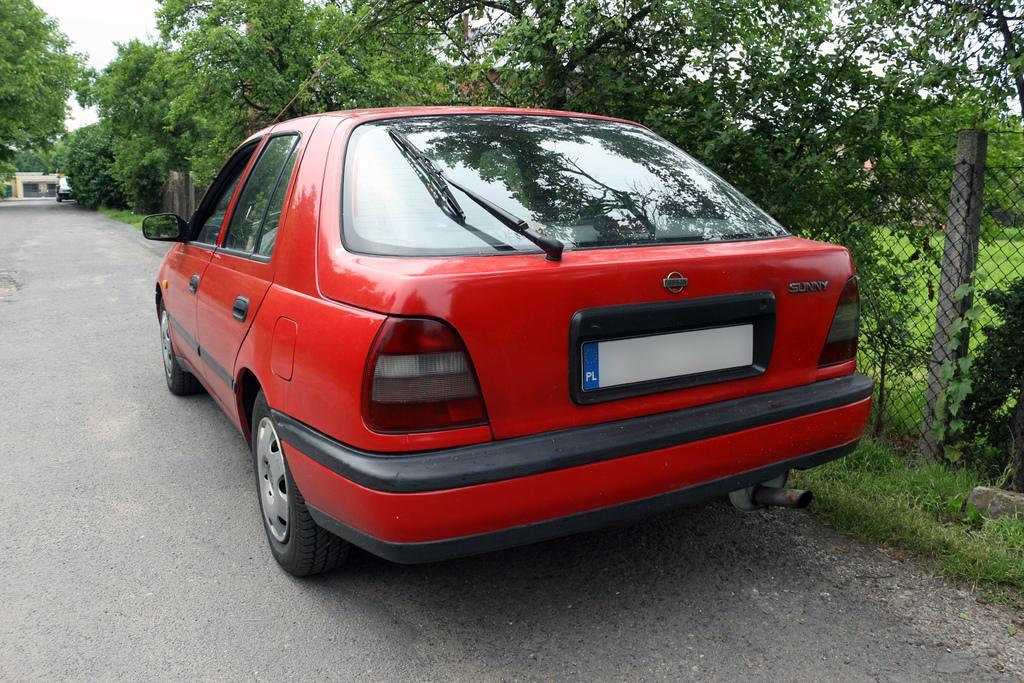How would you summarize this image in a sentence or two? In the center of the image we can see a car on the road. On the right there is a mesh. In the background there are trees and sky. 